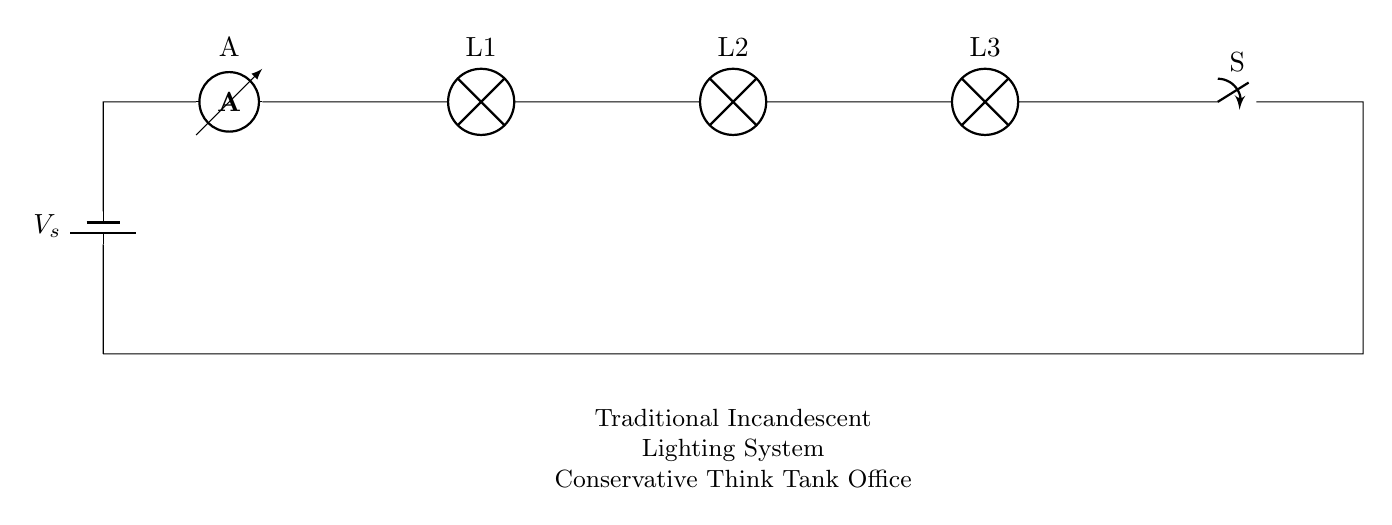What is the total number of lamps connected in the circuit? The circuit diagram shows three lamps connected in a series, labeled as L1, L2, and L3.
Answer: three What component measures current in this circuit? The ammeter is the device specifically used to measure the current flowing through the circuit, as indicated by its label A.
Answer: ammeter What happens to the current if one lamp burns out? In a series circuit like this one, if one lamp (e.g., L1, L2, or L3) fails, the circuit is broken and current ceases to flow, thus all lamps would turn off.
Answer: all turn off What is the function of the switch in this circuit? The switch allows for the control of the current flow in the circuit, enabling the user to open (break) or close (complete) the circuit as desired.
Answer: control current flow If the voltage supplied by the battery is 12 volts, what would be the voltage drop across each lamp assuming they are identical? In a series circuit, the total voltage is divided evenly among all identical components; therefore, with a 12-volt supply and three identical lamps, the voltage drop across each lamp would be 4 volts.
Answer: 4 volts What type of circuit is depicted? The circuit is a series circuit, which is characterized by all components being connected in a single path where the same current flows through each component.
Answer: series circuit 